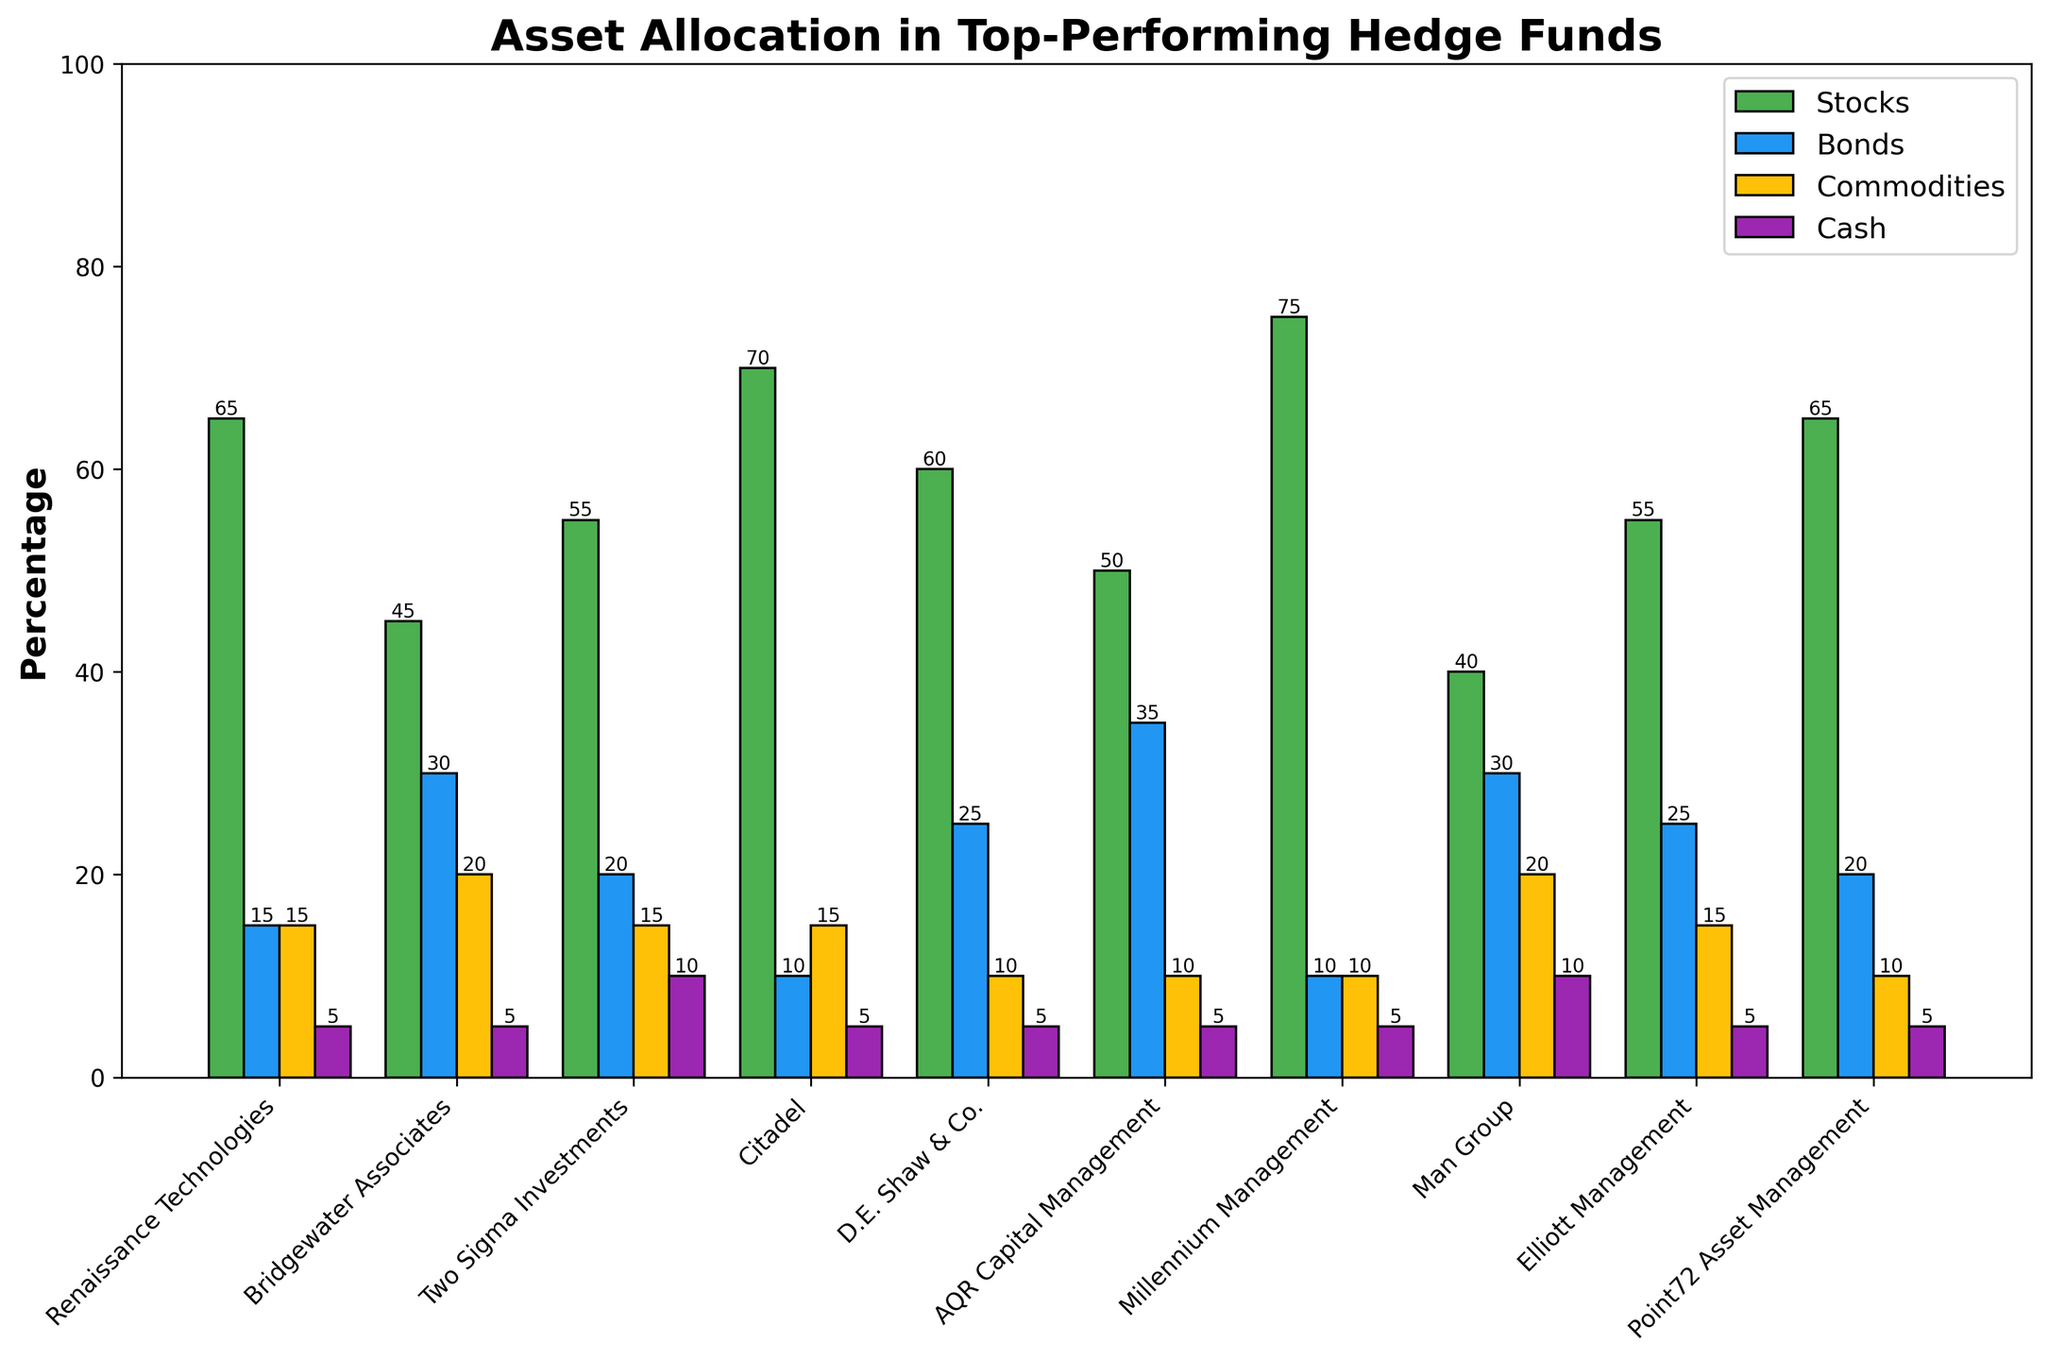What is the total percentage of Renaissance Technologies' assets allocated to Stocks and Bonds? The percentage of assets allocated to Stocks for Renaissance Technologies is 65%, and for Bonds, it is 15%. Adding these together: 65 + 15 = 80%.
Answer: 80% Which hedge fund has the highest allocation in Stocks? Observing the height of the green bars representing Stocks, Millennium Management has the highest allocation with 75%.
Answer: Millennium Management Compare Bridgewater Associates and Man Group in terms of their allocation in Commodities. Which fund allocates more? Bridgewater Associates allocates 20% to Commodities, while Man Group also allocates 20%. Both hedge funds allocate the same percentage to Commodities.
Answer: Same What is the difference in the allocation to Cash between Two Sigma Investments and D.E. Shaw & Co.? Two Sigma Investments allocates 10% to Cash, and D.E. Shaw & Co. allocates 5% to Cash. The difference is 10 - 5 = 5%.
Answer: 5% Which color represents Cash in the chart? The purple bars in the chart represent the allocation to Cash.
Answer: Purple What is the total percentage allocated to Bonds across all hedge funds? Summing the Bonds percentages for all hedge funds: 15 + 30 + 20 + 10 + 25 + 35 + 10 + 30 + 25 + 20 = 220%. To simplify the explanation, each value should be verified in the corresponding bar color.
Answer: 220% Identify the hedge fund with the smallest allocation to Stocks. What is the percentage? By looking at the height of the green bars, Man Group has the smallest allocation to Stocks with 40%.
Answer: Man Group, 40% For Citadel, by how much does the allocation to Stocks exceed that of Commodities? Citadel allocates 70% to Stocks and 15% to Commodities. The difference is 70 - 15 = 55%.
Answer: 55% What is the average percentage allocation to Cash across all hedge funds? Summing the percentages of Cash allocation: 5+5+10+5+5+5+5+10+5+5 = 60%, and dividing it by the number of hedge funds (10): 60/10 = 6%.
Answer: 6% Which hedge fund has an equal percentage allocation to Stocks and Commodities? None of the hedge funds have an equal percentage allocation to Stocks and Commodities as observed by comparing the heights of the green and yellow bars for each fund.
Answer: None 